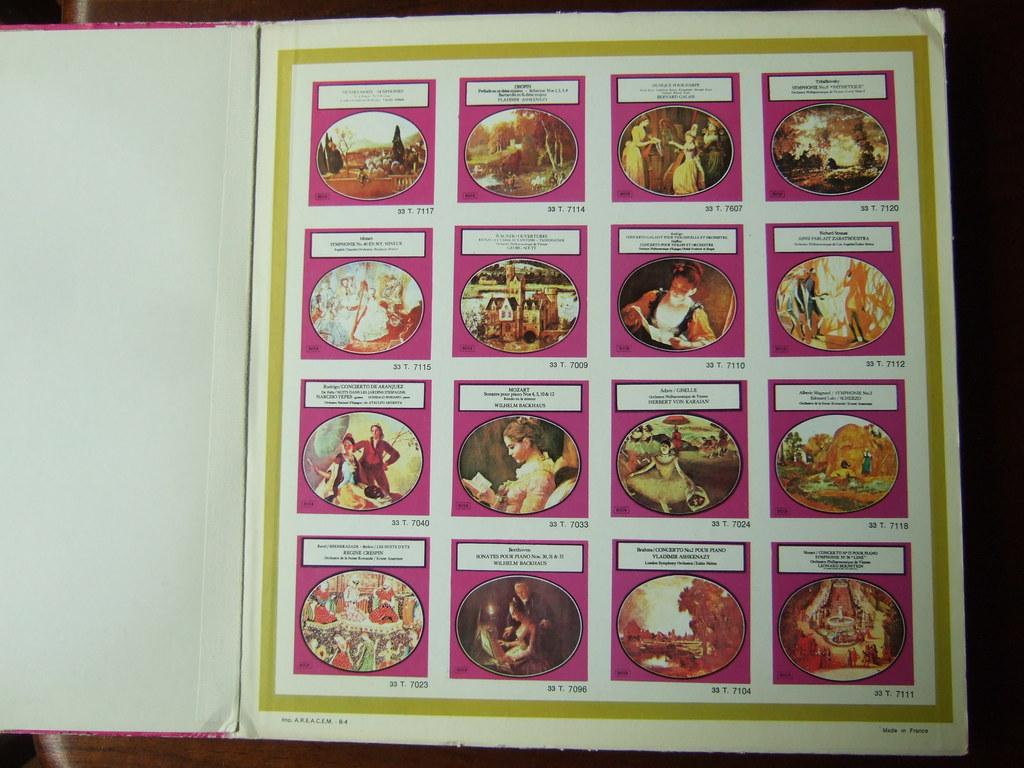What is the main feature of the book in the image? There is a collage of images in the book. Can you describe the collage in more detail? Unfortunately, the image does not provide enough detail to describe the collage further. What type of berry is being used to create the collage in the image? There is no mention of berries being used in the collage, as the image only shows a collage of images in the book. 